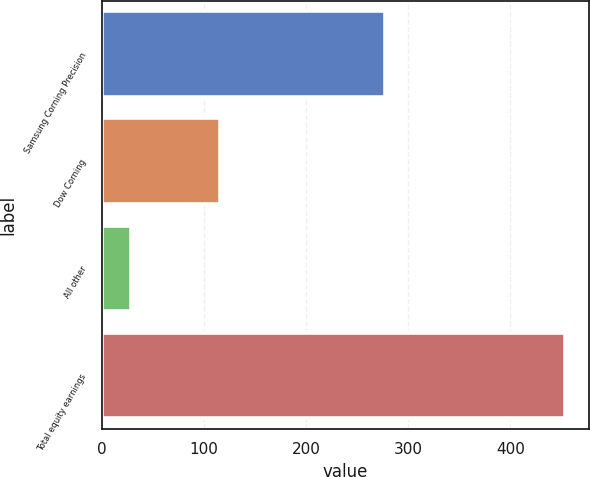Convert chart to OTSL. <chart><loc_0><loc_0><loc_500><loc_500><bar_chart><fcel>Samsung Corning Precision<fcel>Dow Corning<fcel>All other<fcel>Total equity earnings<nl><fcel>277<fcel>116<fcel>29<fcel>454<nl></chart> 